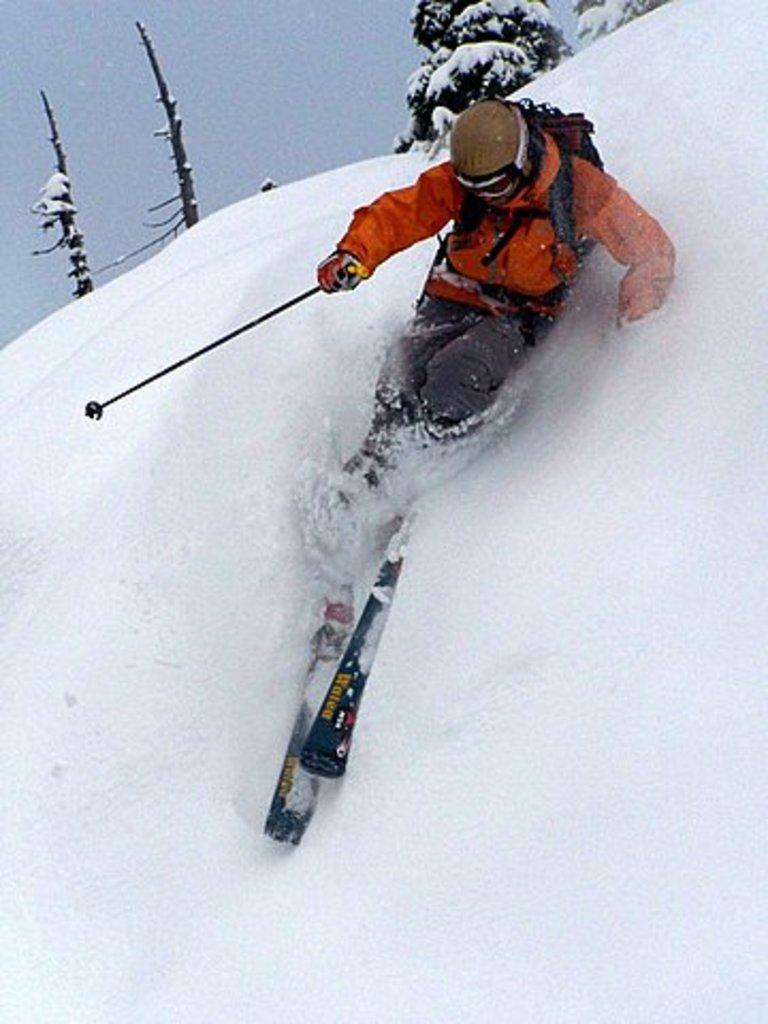What is the main subject in the foreground of the image? There is a man in the foreground of the image. What is the man doing in the image? The man is skiing on the snow. What is the man holding while skiing? The man is holding trekking sticks. What can be seen in the background of the image? There are trees and the sky visible in the background of the image. What type of cabbage is growing on the man's head in the image? There is no cabbage present in the image, and the man's head is not shown. 